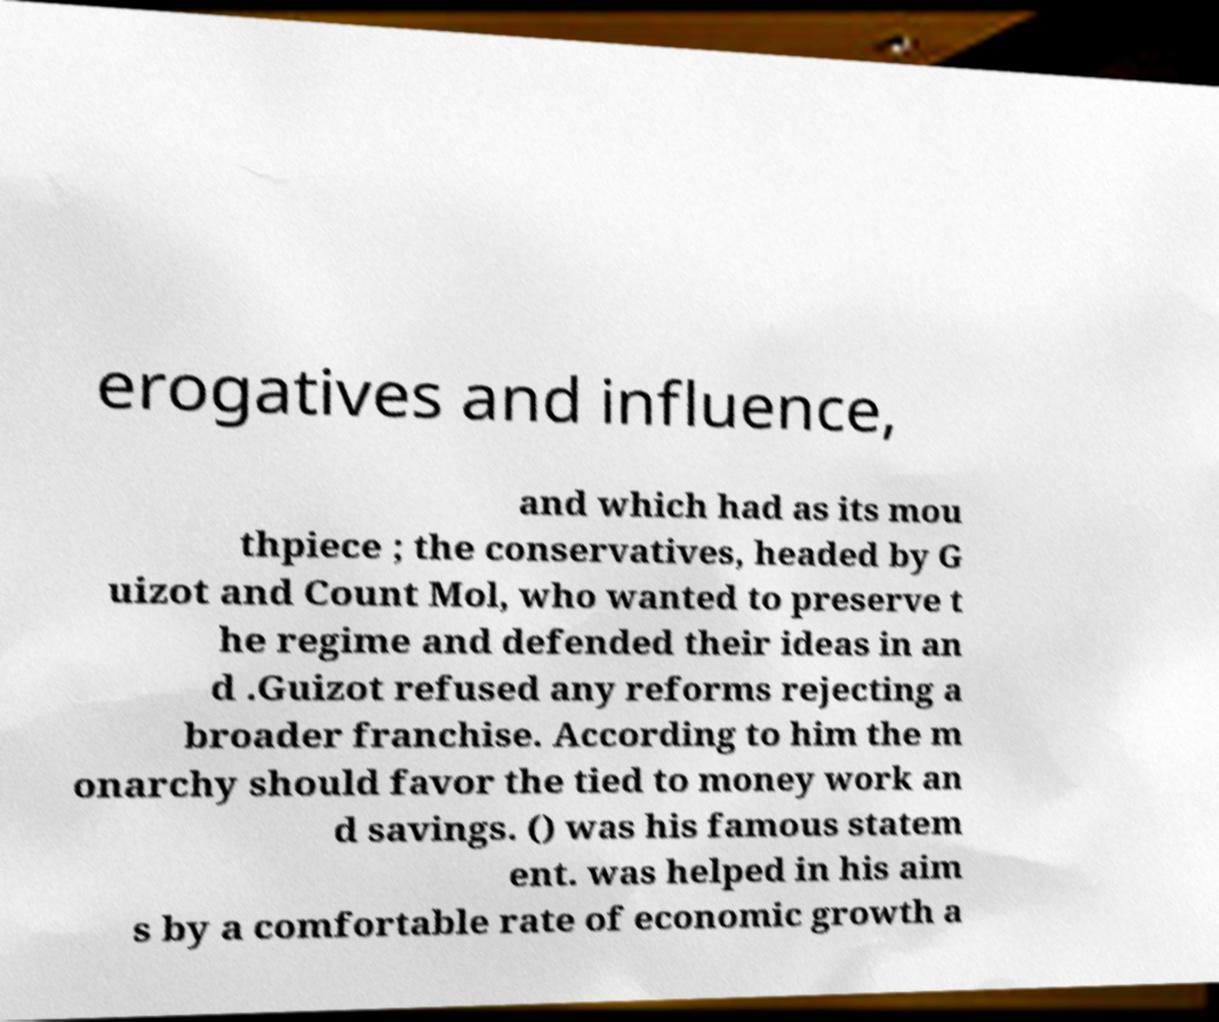For documentation purposes, I need the text within this image transcribed. Could you provide that? erogatives and influence, and which had as its mou thpiece ; the conservatives, headed by G uizot and Count Mol, who wanted to preserve t he regime and defended their ideas in an d .Guizot refused any reforms rejecting a broader franchise. According to him the m onarchy should favor the tied to money work an d savings. () was his famous statem ent. was helped in his aim s by a comfortable rate of economic growth a 